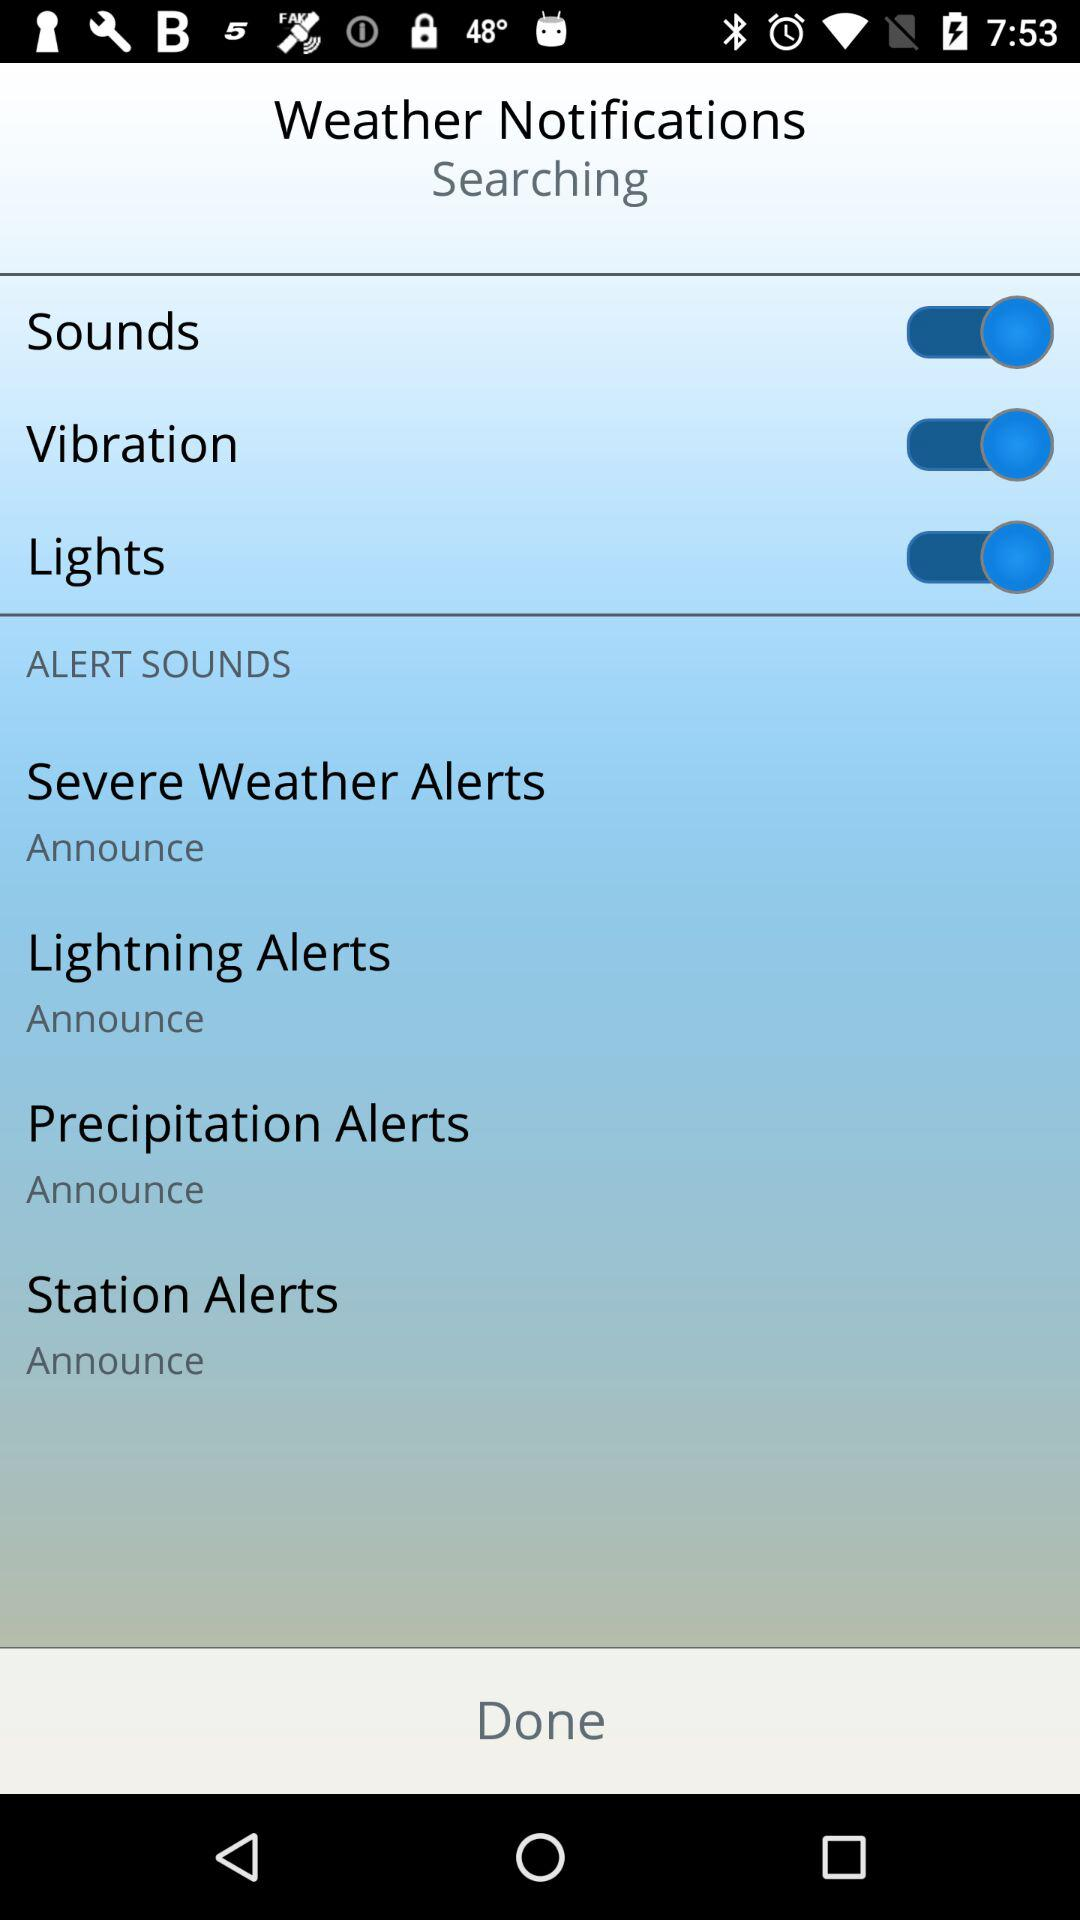How many alert sounds are there?
Answer the question using a single word or phrase. 4 